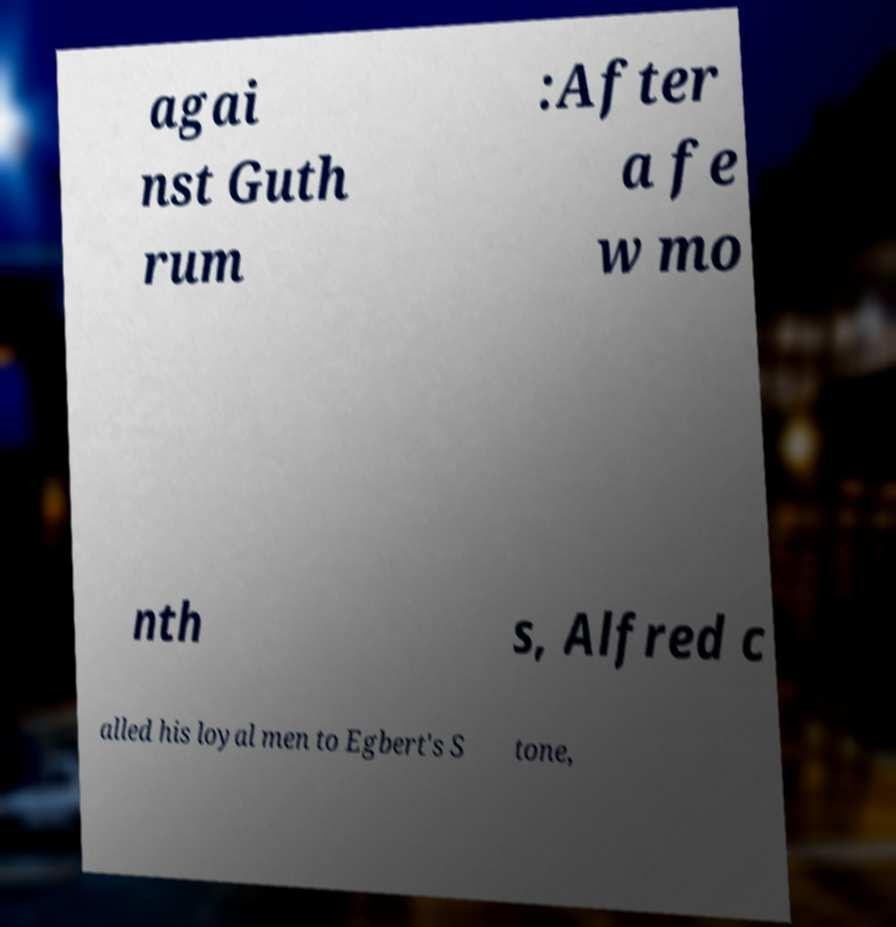Please identify and transcribe the text found in this image. agai nst Guth rum :After a fe w mo nth s, Alfred c alled his loyal men to Egbert's S tone, 